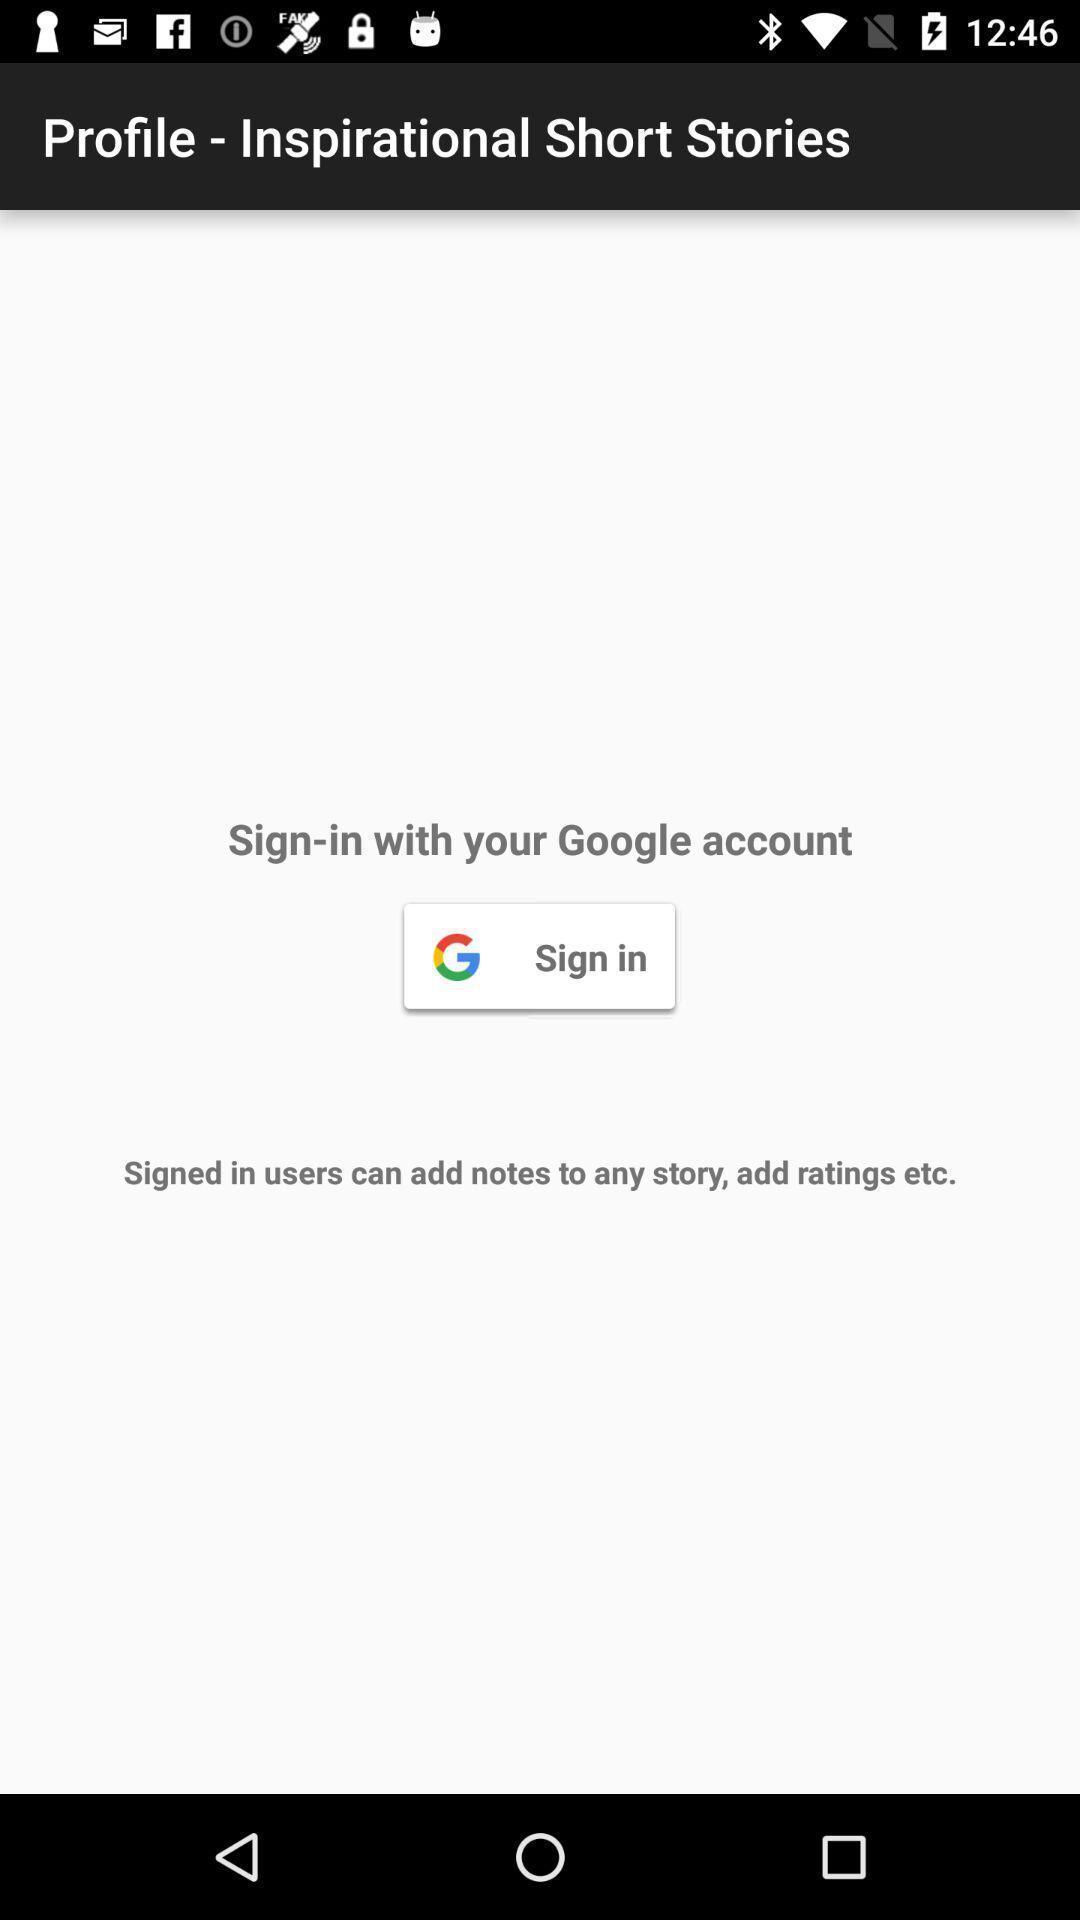Explain the elements present in this screenshot. Sign-in page showing features of the app. 